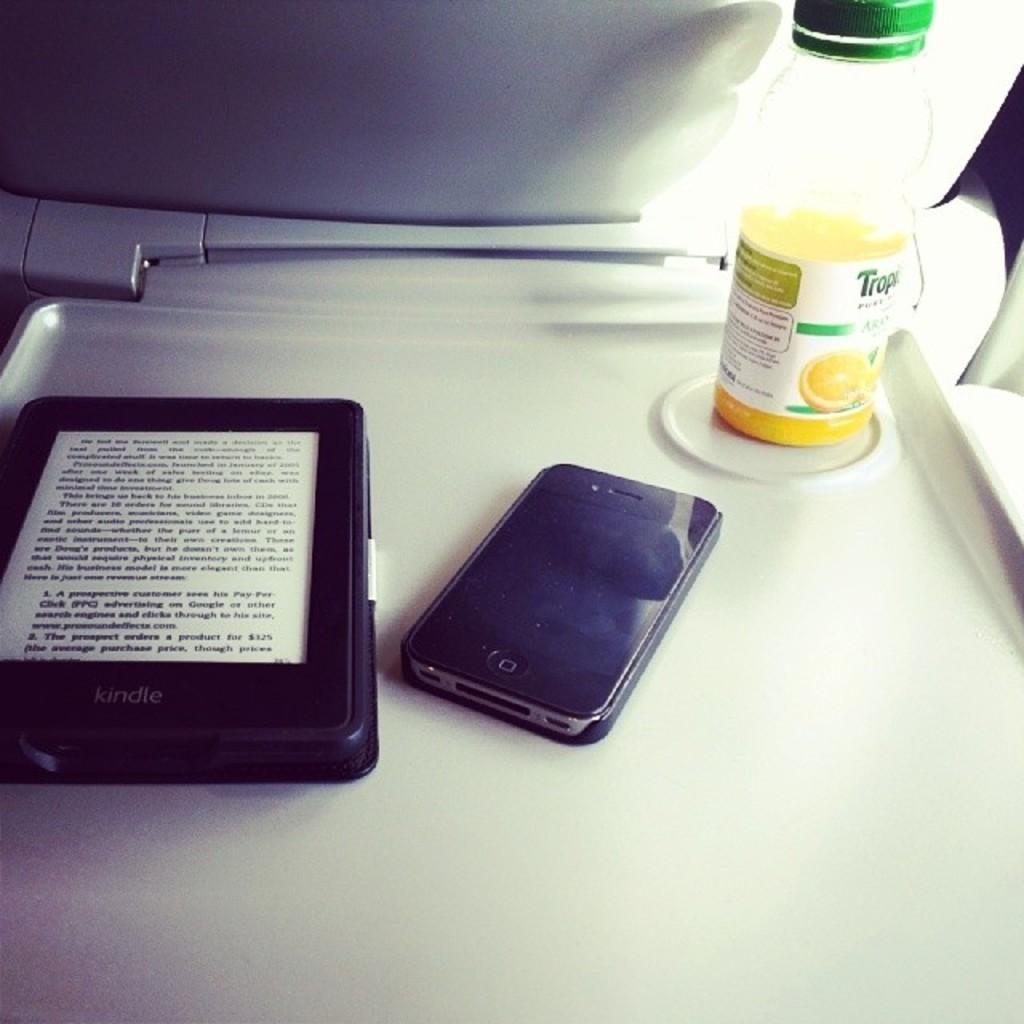Describe this image in one or two sentences. In this picture, There a plate of white color and there is a black color object,In the middle there is a cell phone in black color, In the right side there is a bottle which contains yellow color liquid. 